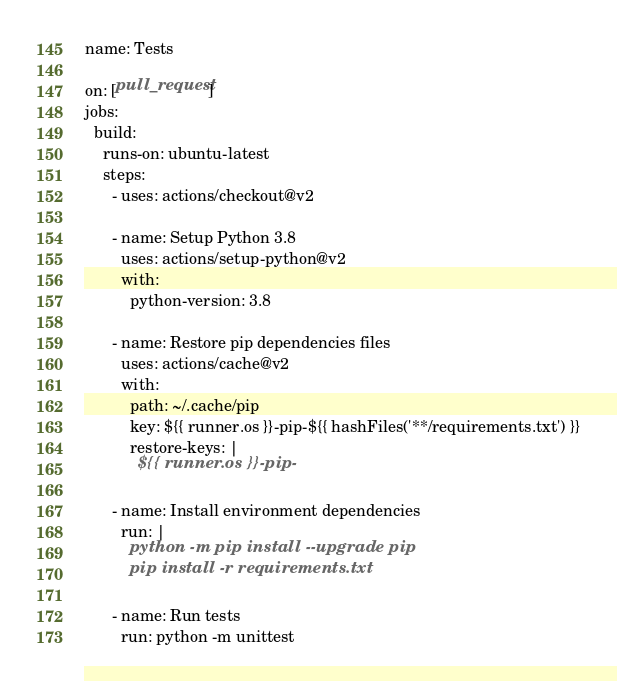<code> <loc_0><loc_0><loc_500><loc_500><_YAML_>name: Tests

on: [pull_request]
jobs:
  build:
    runs-on: ubuntu-latest
    steps:
      - uses: actions/checkout@v2

      - name: Setup Python 3.8
        uses: actions/setup-python@v2
        with:
          python-version: 3.8

      - name: Restore pip dependencies files
        uses: actions/cache@v2
        with:
          path: ~/.cache/pip
          key: ${{ runner.os }}-pip-${{ hashFiles('**/requirements.txt') }}
          restore-keys: |
            ${{ runner.os }}-pip-

      - name: Install environment dependencies
        run: |
          python -m pip install --upgrade pip
          pip install -r requirements.txt

      - name: Run tests
        run: python -m unittest
</code> 